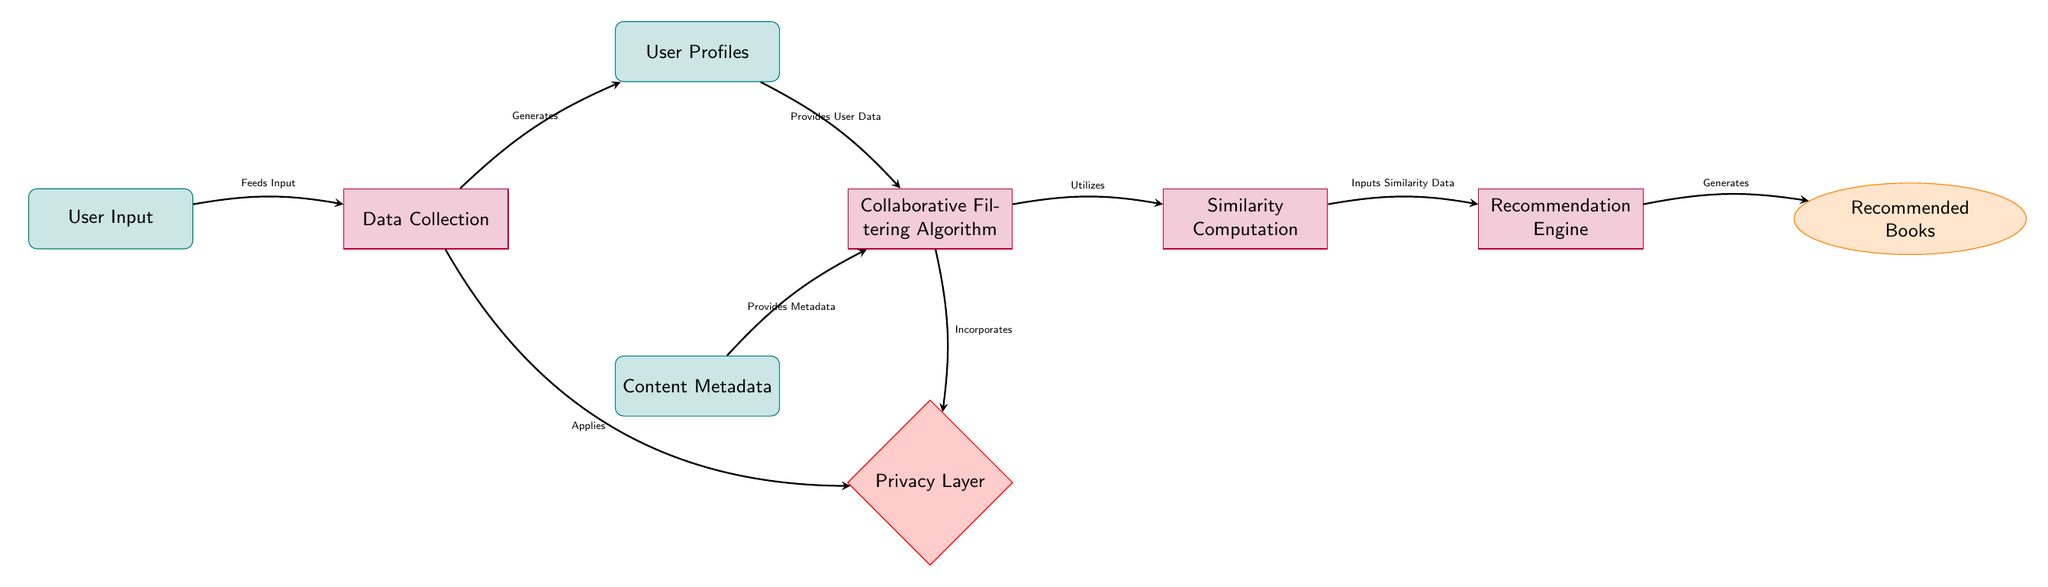What is the first node in the diagram? The diagram starts with "User Input" as it is the initial point where the process begins, and it flows into the next step, "Data Collection."
Answer: User Input How many processes are shown in the diagram? The diagram displays four process nodes: "Data Collection," "Collaborative Filtering Algorithm," "Similarity Computation," and "Recommendation Engine." Counting these nodes gives us a total of four processes.
Answer: 4 What does the "Data Collection" node generate? The "Data Collection" node is connected to "User Profiles," indicating that it generates user profiles based on the input data collected, which is represented by the arrow from "Data Collection" to "User Profiles."
Answer: User Profiles Which node provides metadata to the "Collaborative Filtering Algorithm"? The "Content Metadata" node is the one that provides the necessary content metadata to the "Collaborative Filtering Algorithm," as indicated by the direct connection in the diagram.
Answer: Content Metadata What is the role of the "Privacy Layer" in this diagram? The "Privacy Layer" is integrated below the "Collaborative Filtering" process and receives input from "Data Collection" and incorporates it, thus enhancing the overall privacy aspect of the recommendation system.
Answer: Enhancing privacy Which process receives similarity data as input? The "Recommendation Engine" receives input from "Similarity Computation," which provides similarity data necessary for generating recommendations, as indicated by the flow of arrows.
Answer: Recommendation Engine How many data nodes are present in the diagram? The diagram contains three data nodes: "User Input," "User Profiles," and "Content Metadata." Therefore, by counting these, we can determine that there are three data nodes in total.
Answer: 3 What processes are connected to the "Privacy Layer"? The "Privacy Layer" is connected to two processes: "Data Collection" (through a bend in the arrow) and "Collaborative Filtering Algorithm," which shows that both processes consider privacy measures in their operations.
Answer: Data Collection and Collaborative Filtering Algorithm What is the final output of the recommendation system? The "Recommended Books" node is the final output of the recommendation system, as indicated by the flow from the "Recommendation Engine," making it the output node of the entire process.
Answer: Recommended Books 